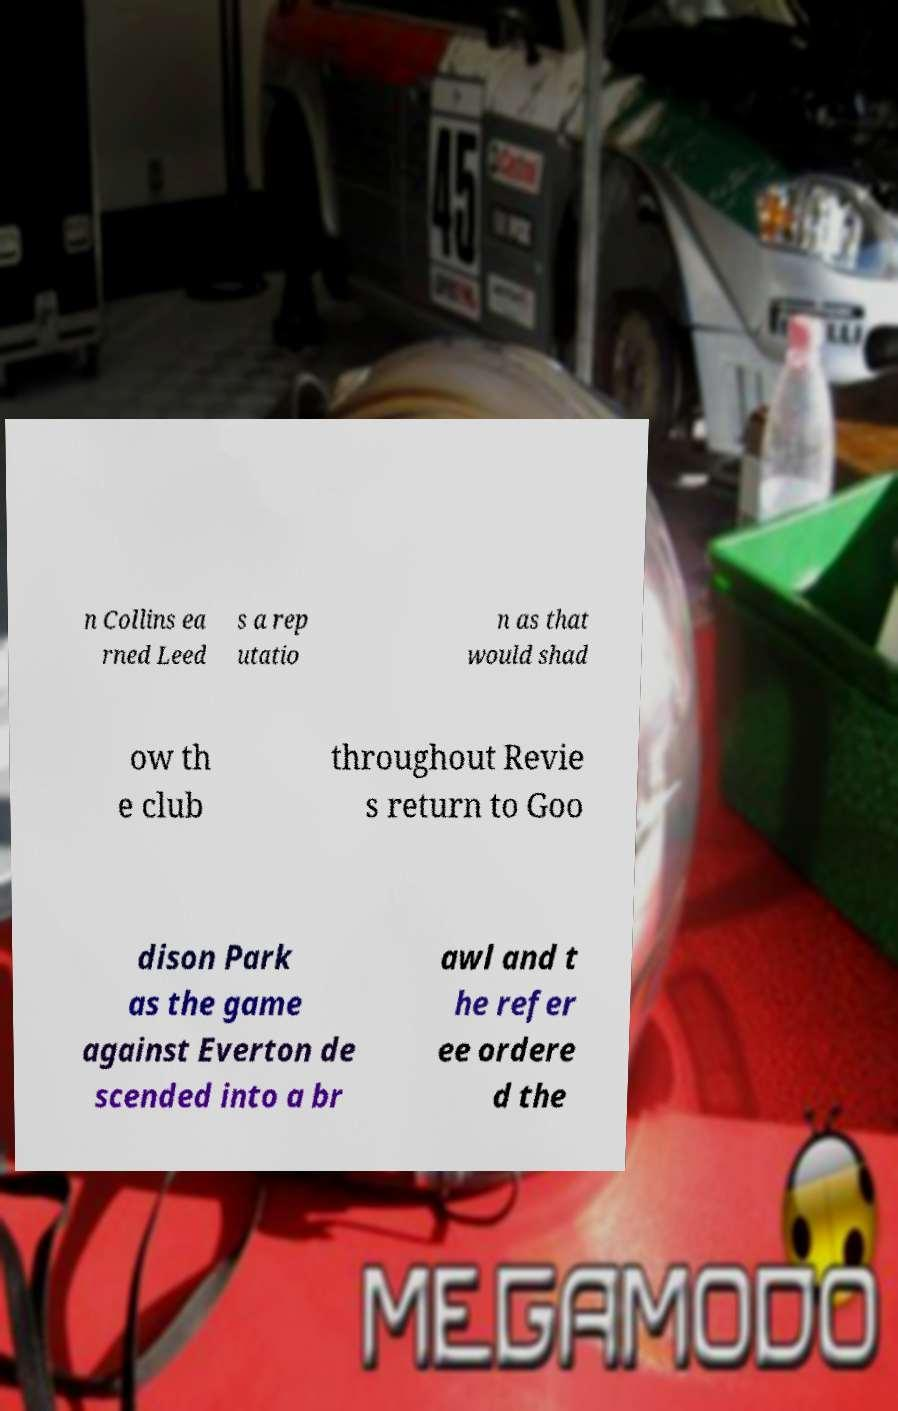I need the written content from this picture converted into text. Can you do that? n Collins ea rned Leed s a rep utatio n as that would shad ow th e club throughout Revie s return to Goo dison Park as the game against Everton de scended into a br awl and t he refer ee ordere d the 